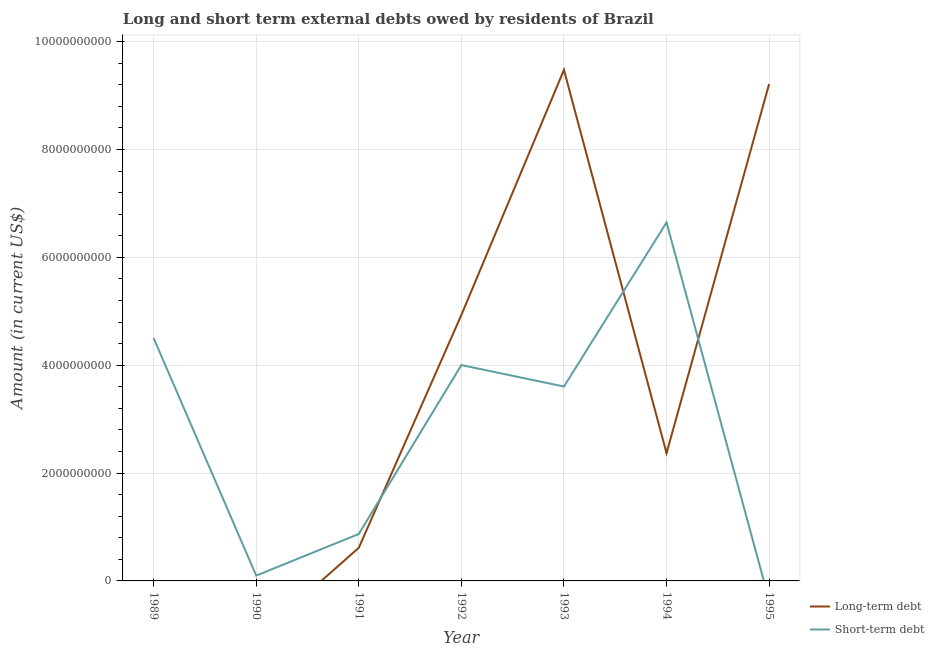How many different coloured lines are there?
Your answer should be very brief. 2. Does the line corresponding to long-term debts owed by residents intersect with the line corresponding to short-term debts owed by residents?
Keep it short and to the point. Yes. What is the short-term debts owed by residents in 1994?
Your answer should be very brief. 6.65e+09. Across all years, what is the maximum long-term debts owed by residents?
Provide a succinct answer. 9.48e+09. Across all years, what is the minimum short-term debts owed by residents?
Ensure brevity in your answer.  0. What is the total long-term debts owed by residents in the graph?
Make the answer very short. 2.66e+1. What is the difference between the short-term debts owed by residents in 1990 and that in 1993?
Keep it short and to the point. -3.51e+09. What is the difference between the long-term debts owed by residents in 1989 and the short-term debts owed by residents in 1993?
Provide a short and direct response. -3.60e+09. What is the average short-term debts owed by residents per year?
Keep it short and to the point. 2.82e+09. In the year 1992, what is the difference between the long-term debts owed by residents and short-term debts owed by residents?
Offer a very short reply. 9.29e+08. What is the ratio of the short-term debts owed by residents in 1989 to that in 1993?
Offer a very short reply. 1.25. Is the short-term debts owed by residents in 1991 less than that in 1992?
Your response must be concise. Yes. Is the difference between the short-term debts owed by residents in 1992 and 1994 greater than the difference between the long-term debts owed by residents in 1992 and 1994?
Provide a short and direct response. No. What is the difference between the highest and the second highest long-term debts owed by residents?
Keep it short and to the point. 2.62e+08. What is the difference between the highest and the lowest long-term debts owed by residents?
Give a very brief answer. 9.48e+09. In how many years, is the long-term debts owed by residents greater than the average long-term debts owed by residents taken over all years?
Provide a succinct answer. 3. Is the sum of the short-term debts owed by residents in 1992 and 1993 greater than the maximum long-term debts owed by residents across all years?
Keep it short and to the point. No. Does the short-term debts owed by residents monotonically increase over the years?
Keep it short and to the point. No. How many years are there in the graph?
Provide a succinct answer. 7. What is the difference between two consecutive major ticks on the Y-axis?
Offer a terse response. 2.00e+09. Are the values on the major ticks of Y-axis written in scientific E-notation?
Provide a succinct answer. No. Where does the legend appear in the graph?
Provide a succinct answer. Bottom right. How are the legend labels stacked?
Your answer should be very brief. Vertical. What is the title of the graph?
Ensure brevity in your answer.  Long and short term external debts owed by residents of Brazil. Does "Food" appear as one of the legend labels in the graph?
Your answer should be very brief. No. What is the Amount (in current US$) in Long-term debt in 1989?
Your answer should be very brief. 0. What is the Amount (in current US$) of Short-term debt in 1989?
Provide a succinct answer. 4.50e+09. What is the Amount (in current US$) in Short-term debt in 1990?
Make the answer very short. 9.90e+07. What is the Amount (in current US$) of Long-term debt in 1991?
Keep it short and to the point. 6.14e+08. What is the Amount (in current US$) of Short-term debt in 1991?
Your answer should be compact. 8.70e+08. What is the Amount (in current US$) in Long-term debt in 1992?
Keep it short and to the point. 4.93e+09. What is the Amount (in current US$) in Short-term debt in 1992?
Your answer should be compact. 4.00e+09. What is the Amount (in current US$) of Long-term debt in 1993?
Your answer should be compact. 9.48e+09. What is the Amount (in current US$) in Short-term debt in 1993?
Your answer should be very brief. 3.60e+09. What is the Amount (in current US$) of Long-term debt in 1994?
Provide a short and direct response. 2.37e+09. What is the Amount (in current US$) in Short-term debt in 1994?
Offer a very short reply. 6.65e+09. What is the Amount (in current US$) of Long-term debt in 1995?
Make the answer very short. 9.22e+09. What is the Amount (in current US$) of Short-term debt in 1995?
Provide a short and direct response. 0. Across all years, what is the maximum Amount (in current US$) of Long-term debt?
Make the answer very short. 9.48e+09. Across all years, what is the maximum Amount (in current US$) of Short-term debt?
Make the answer very short. 6.65e+09. What is the total Amount (in current US$) in Long-term debt in the graph?
Offer a very short reply. 2.66e+1. What is the total Amount (in current US$) in Short-term debt in the graph?
Provide a short and direct response. 1.97e+1. What is the difference between the Amount (in current US$) in Short-term debt in 1989 and that in 1990?
Provide a succinct answer. 4.40e+09. What is the difference between the Amount (in current US$) of Short-term debt in 1989 and that in 1991?
Keep it short and to the point. 3.63e+09. What is the difference between the Amount (in current US$) of Short-term debt in 1989 and that in 1992?
Your answer should be very brief. 5.00e+08. What is the difference between the Amount (in current US$) of Short-term debt in 1989 and that in 1993?
Give a very brief answer. 8.98e+08. What is the difference between the Amount (in current US$) of Short-term debt in 1989 and that in 1994?
Keep it short and to the point. -2.14e+09. What is the difference between the Amount (in current US$) in Short-term debt in 1990 and that in 1991?
Provide a succinct answer. -7.71e+08. What is the difference between the Amount (in current US$) of Short-term debt in 1990 and that in 1992?
Keep it short and to the point. -3.90e+09. What is the difference between the Amount (in current US$) in Short-term debt in 1990 and that in 1993?
Give a very brief answer. -3.51e+09. What is the difference between the Amount (in current US$) of Short-term debt in 1990 and that in 1994?
Give a very brief answer. -6.55e+09. What is the difference between the Amount (in current US$) of Long-term debt in 1991 and that in 1992?
Provide a succinct answer. -4.32e+09. What is the difference between the Amount (in current US$) of Short-term debt in 1991 and that in 1992?
Ensure brevity in your answer.  -3.13e+09. What is the difference between the Amount (in current US$) in Long-term debt in 1991 and that in 1993?
Provide a short and direct response. -8.86e+09. What is the difference between the Amount (in current US$) in Short-term debt in 1991 and that in 1993?
Offer a very short reply. -2.74e+09. What is the difference between the Amount (in current US$) in Long-term debt in 1991 and that in 1994?
Your answer should be compact. -1.75e+09. What is the difference between the Amount (in current US$) of Short-term debt in 1991 and that in 1994?
Provide a short and direct response. -5.78e+09. What is the difference between the Amount (in current US$) of Long-term debt in 1991 and that in 1995?
Offer a very short reply. -8.60e+09. What is the difference between the Amount (in current US$) in Long-term debt in 1992 and that in 1993?
Provide a short and direct response. -4.55e+09. What is the difference between the Amount (in current US$) in Short-term debt in 1992 and that in 1993?
Your response must be concise. 3.98e+08. What is the difference between the Amount (in current US$) in Long-term debt in 1992 and that in 1994?
Ensure brevity in your answer.  2.56e+09. What is the difference between the Amount (in current US$) in Short-term debt in 1992 and that in 1994?
Provide a short and direct response. -2.64e+09. What is the difference between the Amount (in current US$) in Long-term debt in 1992 and that in 1995?
Your answer should be very brief. -4.28e+09. What is the difference between the Amount (in current US$) in Long-term debt in 1993 and that in 1994?
Provide a succinct answer. 7.11e+09. What is the difference between the Amount (in current US$) of Short-term debt in 1993 and that in 1994?
Provide a short and direct response. -3.04e+09. What is the difference between the Amount (in current US$) in Long-term debt in 1993 and that in 1995?
Provide a short and direct response. 2.62e+08. What is the difference between the Amount (in current US$) in Long-term debt in 1994 and that in 1995?
Provide a short and direct response. -6.85e+09. What is the difference between the Amount (in current US$) in Long-term debt in 1991 and the Amount (in current US$) in Short-term debt in 1992?
Offer a terse response. -3.39e+09. What is the difference between the Amount (in current US$) of Long-term debt in 1991 and the Amount (in current US$) of Short-term debt in 1993?
Give a very brief answer. -2.99e+09. What is the difference between the Amount (in current US$) of Long-term debt in 1991 and the Amount (in current US$) of Short-term debt in 1994?
Offer a terse response. -6.03e+09. What is the difference between the Amount (in current US$) of Long-term debt in 1992 and the Amount (in current US$) of Short-term debt in 1993?
Provide a short and direct response. 1.33e+09. What is the difference between the Amount (in current US$) of Long-term debt in 1992 and the Amount (in current US$) of Short-term debt in 1994?
Offer a very short reply. -1.72e+09. What is the difference between the Amount (in current US$) of Long-term debt in 1993 and the Amount (in current US$) of Short-term debt in 1994?
Your answer should be compact. 2.83e+09. What is the average Amount (in current US$) in Long-term debt per year?
Offer a terse response. 3.80e+09. What is the average Amount (in current US$) of Short-term debt per year?
Your answer should be very brief. 2.82e+09. In the year 1991, what is the difference between the Amount (in current US$) in Long-term debt and Amount (in current US$) in Short-term debt?
Provide a succinct answer. -2.56e+08. In the year 1992, what is the difference between the Amount (in current US$) of Long-term debt and Amount (in current US$) of Short-term debt?
Your answer should be very brief. 9.29e+08. In the year 1993, what is the difference between the Amount (in current US$) in Long-term debt and Amount (in current US$) in Short-term debt?
Ensure brevity in your answer.  5.87e+09. In the year 1994, what is the difference between the Amount (in current US$) of Long-term debt and Amount (in current US$) of Short-term debt?
Provide a succinct answer. -4.28e+09. What is the ratio of the Amount (in current US$) of Short-term debt in 1989 to that in 1990?
Offer a very short reply. 45.49. What is the ratio of the Amount (in current US$) in Short-term debt in 1989 to that in 1991?
Offer a terse response. 5.18. What is the ratio of the Amount (in current US$) of Short-term debt in 1989 to that in 1993?
Provide a short and direct response. 1.25. What is the ratio of the Amount (in current US$) in Short-term debt in 1989 to that in 1994?
Give a very brief answer. 0.68. What is the ratio of the Amount (in current US$) of Short-term debt in 1990 to that in 1991?
Your answer should be compact. 0.11. What is the ratio of the Amount (in current US$) of Short-term debt in 1990 to that in 1992?
Make the answer very short. 0.02. What is the ratio of the Amount (in current US$) of Short-term debt in 1990 to that in 1993?
Keep it short and to the point. 0.03. What is the ratio of the Amount (in current US$) in Short-term debt in 1990 to that in 1994?
Keep it short and to the point. 0.01. What is the ratio of the Amount (in current US$) of Long-term debt in 1991 to that in 1992?
Ensure brevity in your answer.  0.12. What is the ratio of the Amount (in current US$) in Short-term debt in 1991 to that in 1992?
Offer a terse response. 0.22. What is the ratio of the Amount (in current US$) in Long-term debt in 1991 to that in 1993?
Provide a short and direct response. 0.06. What is the ratio of the Amount (in current US$) in Short-term debt in 1991 to that in 1993?
Your answer should be very brief. 0.24. What is the ratio of the Amount (in current US$) of Long-term debt in 1991 to that in 1994?
Offer a very short reply. 0.26. What is the ratio of the Amount (in current US$) in Short-term debt in 1991 to that in 1994?
Your response must be concise. 0.13. What is the ratio of the Amount (in current US$) in Long-term debt in 1991 to that in 1995?
Keep it short and to the point. 0.07. What is the ratio of the Amount (in current US$) in Long-term debt in 1992 to that in 1993?
Provide a succinct answer. 0.52. What is the ratio of the Amount (in current US$) of Short-term debt in 1992 to that in 1993?
Provide a succinct answer. 1.11. What is the ratio of the Amount (in current US$) in Long-term debt in 1992 to that in 1994?
Your answer should be compact. 2.08. What is the ratio of the Amount (in current US$) in Short-term debt in 1992 to that in 1994?
Offer a very short reply. 0.6. What is the ratio of the Amount (in current US$) of Long-term debt in 1992 to that in 1995?
Ensure brevity in your answer.  0.54. What is the ratio of the Amount (in current US$) in Long-term debt in 1993 to that in 1994?
Your response must be concise. 4. What is the ratio of the Amount (in current US$) of Short-term debt in 1993 to that in 1994?
Provide a succinct answer. 0.54. What is the ratio of the Amount (in current US$) of Long-term debt in 1993 to that in 1995?
Provide a short and direct response. 1.03. What is the ratio of the Amount (in current US$) of Long-term debt in 1994 to that in 1995?
Provide a succinct answer. 0.26. What is the difference between the highest and the second highest Amount (in current US$) of Long-term debt?
Your answer should be compact. 2.62e+08. What is the difference between the highest and the second highest Amount (in current US$) in Short-term debt?
Provide a short and direct response. 2.14e+09. What is the difference between the highest and the lowest Amount (in current US$) in Long-term debt?
Your response must be concise. 9.48e+09. What is the difference between the highest and the lowest Amount (in current US$) in Short-term debt?
Your response must be concise. 6.65e+09. 